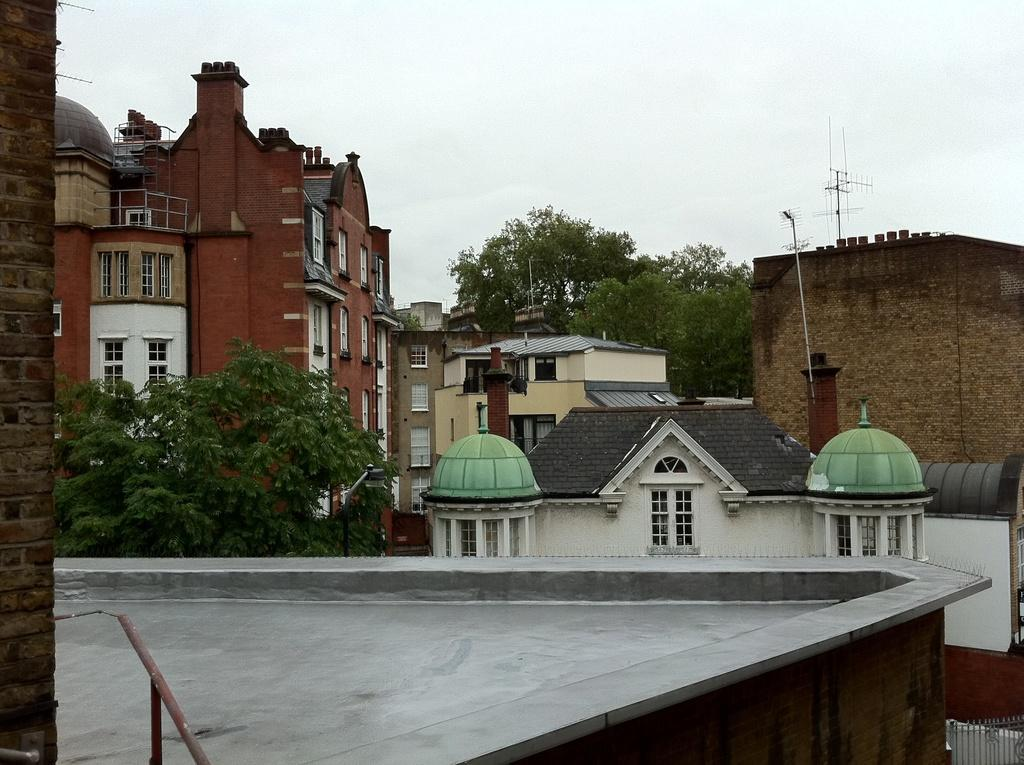What type of structures can be seen in the image? There are buildings in the image. What natural elements are present in the image? There are trees in the image. What architectural features can be observed in the image? There are windows and a railing in the image. What are the rods used for in the image? The purpose of the rods in the image is not specified. What is the weather like in the image? The sky is cloudy in the image. What other unspecified objects can be seen in the image? There are unspecified objects in the image. Can you tell me how many elbows are visible in the image? There are no elbows present in the image. What type of pot is used for cooking in the image? There is no pot present in the image. 